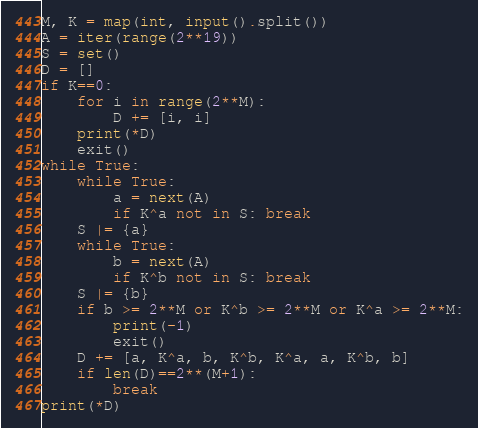<code> <loc_0><loc_0><loc_500><loc_500><_Python_>M, K = map(int, input().split())
A = iter(range(2**19))
S = set()
D = []
if K==0:
    for i in range(2**M):
        D += [i, i]
    print(*D)
    exit()
while True:
    while True:
        a = next(A)
        if K^a not in S: break
    S |= {a}
    while True:
        b = next(A)
        if K^b not in S: break
    S |= {b}
    if b >= 2**M or K^b >= 2**M or K^a >= 2**M:
        print(-1)
        exit()
    D += [a, K^a, b, K^b, K^a, a, K^b, b]
    if len(D)==2**(M+1):
        break
print(*D)</code> 